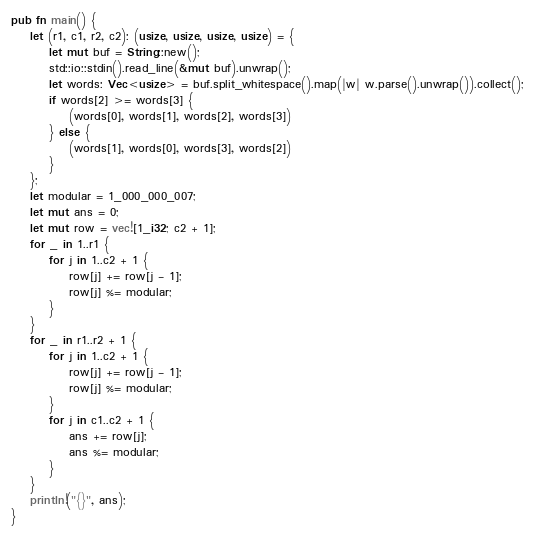Convert code to text. <code><loc_0><loc_0><loc_500><loc_500><_Rust_>pub fn main() {
    let (r1, c1, r2, c2): (usize, usize, usize, usize) = {
        let mut buf = String::new();
        std::io::stdin().read_line(&mut buf).unwrap();
        let words: Vec<usize> = buf.split_whitespace().map(|w| w.parse().unwrap()).collect();
        if words[2] >= words[3] {
            (words[0], words[1], words[2], words[3])
        } else {
            (words[1], words[0], words[3], words[2])
        }
    };
    let modular = 1_000_000_007;
    let mut ans = 0;
    let mut row = vec![1_i32; c2 + 1];
    for _ in 1..r1 {
        for j in 1..c2 + 1 {
            row[j] += row[j - 1];
            row[j] %= modular;
        }
    }
    for _ in r1..r2 + 1 {
        for j in 1..c2 + 1 {
            row[j] += row[j - 1];
            row[j] %= modular;
        }
        for j in c1..c2 + 1 {
            ans += row[j];
            ans %= modular;
        }
    }
    println!("{}", ans);
}</code> 